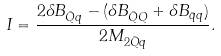Convert formula to latex. <formula><loc_0><loc_0><loc_500><loc_500>I = \frac { 2 \delta B _ { \bar { Q } q } - ( \delta B _ { \bar { Q } Q } + \delta B _ { \bar { q } q } ) } { 2 M _ { 2 \bar { Q } q } } .</formula> 